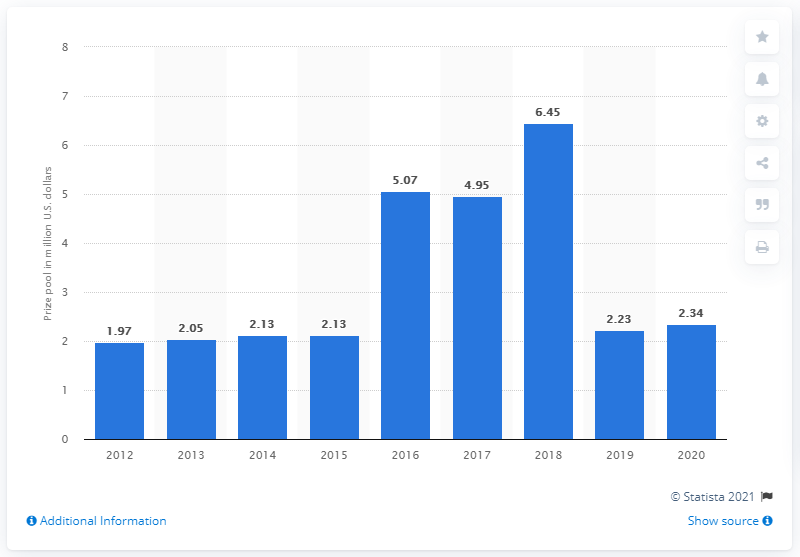Outline some significant characteristics in this image. The prize pool for the previous year's LoL World Championship was 2.23 million dollars. 